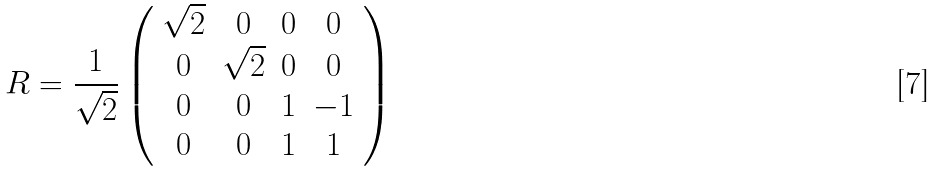Convert formula to latex. <formula><loc_0><loc_0><loc_500><loc_500>R = \frac { 1 } { \sqrt { 2 } } \left ( \begin{array} { c c c c } \sqrt { 2 } & 0 & 0 & 0 \\ 0 & \sqrt { 2 } & 0 & 0 \\ 0 & 0 & 1 & - 1 \\ 0 & 0 & 1 & 1 \end{array} \right )</formula> 